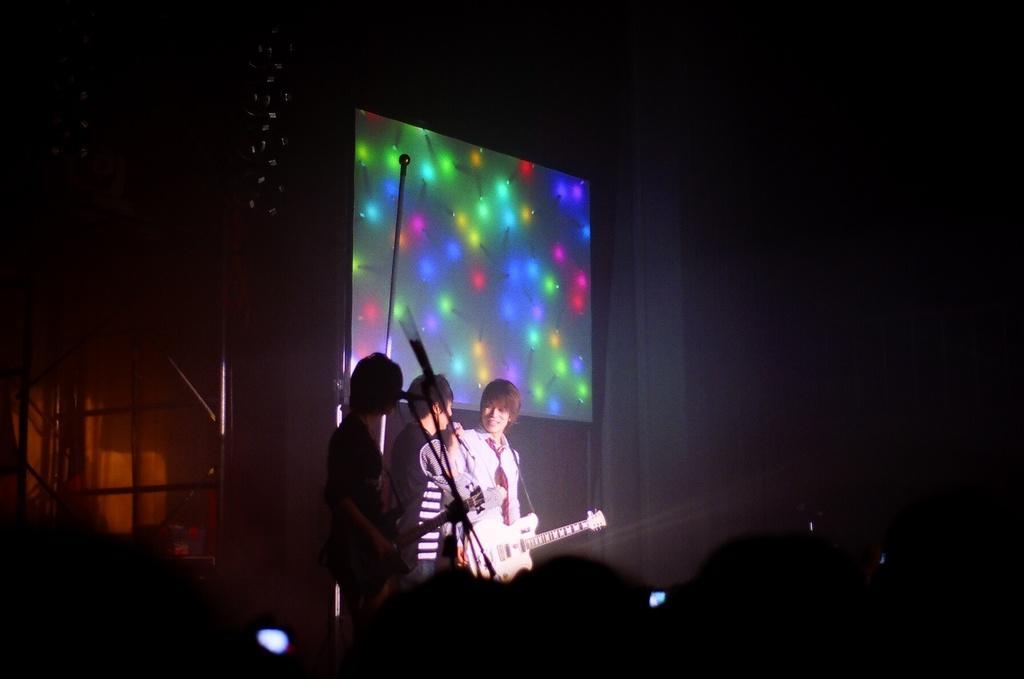Can you describe this image briefly? There are 3 people on the stage performing by playing musical instruments behind them there is a screen. 